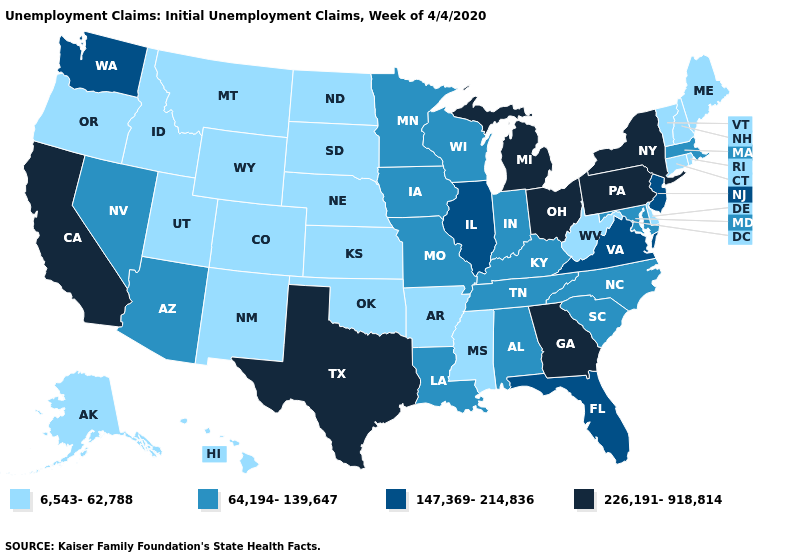What is the highest value in the Northeast ?
Short answer required. 226,191-918,814. What is the lowest value in the South?
Quick response, please. 6,543-62,788. What is the value of Texas?
Answer briefly. 226,191-918,814. What is the value of Oklahoma?
Answer briefly. 6,543-62,788. Which states have the highest value in the USA?
Short answer required. California, Georgia, Michigan, New York, Ohio, Pennsylvania, Texas. Name the states that have a value in the range 6,543-62,788?
Be succinct. Alaska, Arkansas, Colorado, Connecticut, Delaware, Hawaii, Idaho, Kansas, Maine, Mississippi, Montana, Nebraska, New Hampshire, New Mexico, North Dakota, Oklahoma, Oregon, Rhode Island, South Dakota, Utah, Vermont, West Virginia, Wyoming. Does the map have missing data?
Be succinct. No. What is the lowest value in the USA?
Write a very short answer. 6,543-62,788. Does the map have missing data?
Concise answer only. No. Does Alabama have the lowest value in the USA?
Short answer required. No. Does Wisconsin have the highest value in the MidWest?
Write a very short answer. No. What is the value of New Hampshire?
Quick response, please. 6,543-62,788. Does the map have missing data?
Be succinct. No. What is the value of Texas?
Answer briefly. 226,191-918,814. Does North Dakota have the same value as Vermont?
Keep it brief. Yes. 